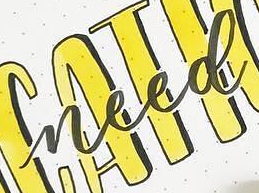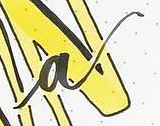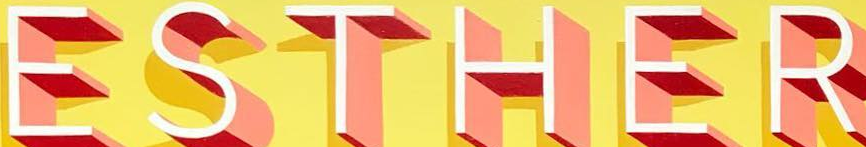Read the text from these images in sequence, separated by a semicolon. need; a; ESTHER 